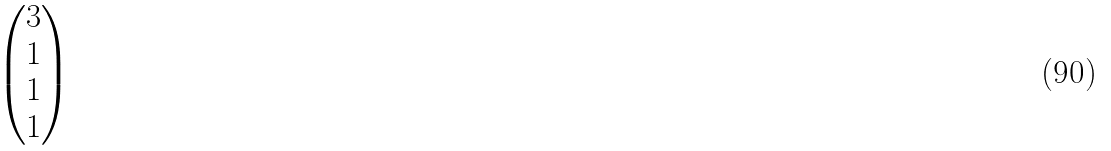<formula> <loc_0><loc_0><loc_500><loc_500>\begin{pmatrix} 3 \\ 1 \\ 1 \\ 1 \\ \end{pmatrix}</formula> 